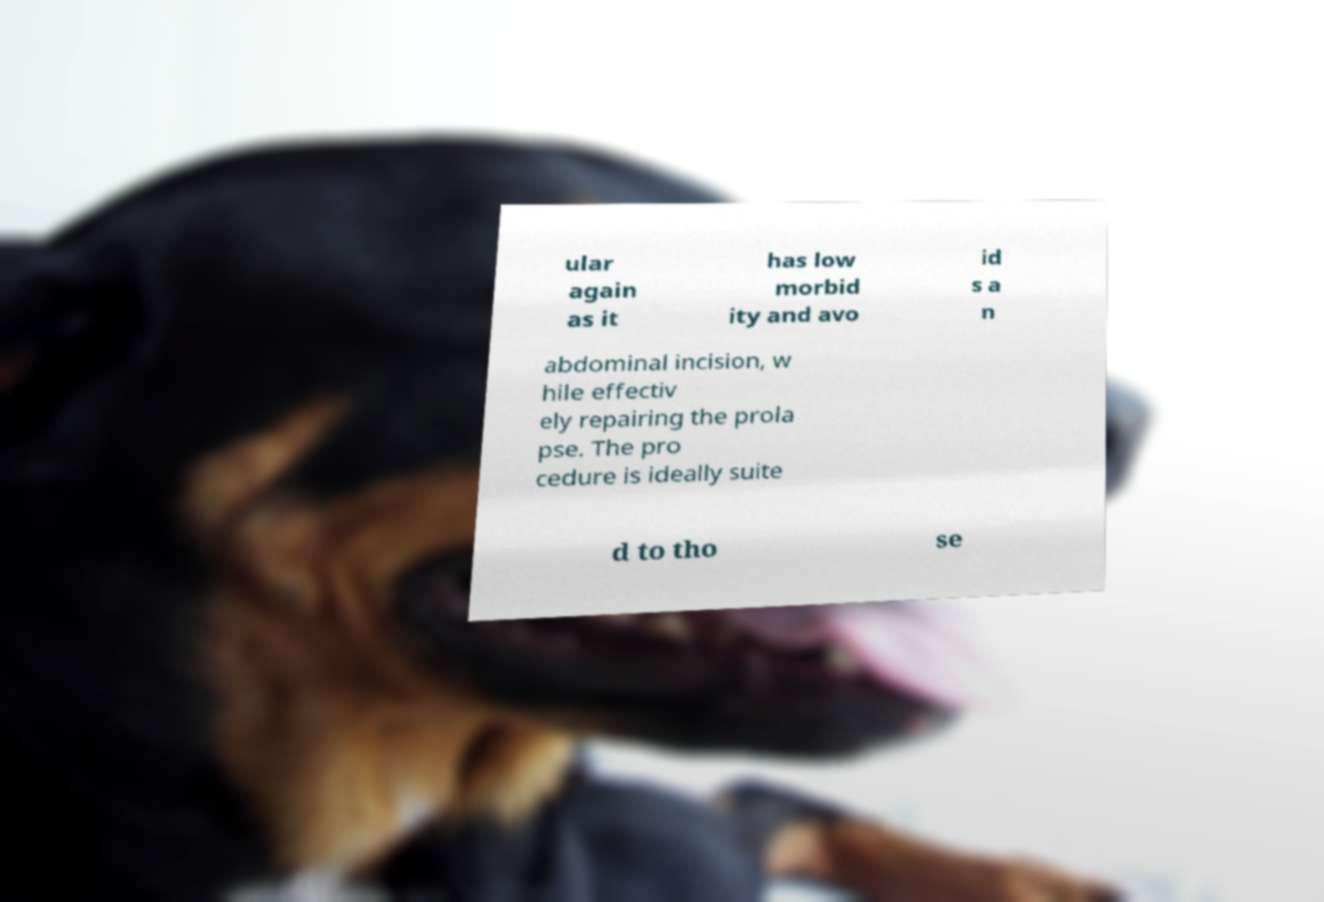Please read and relay the text visible in this image. What does it say? ular again as it has low morbid ity and avo id s a n abdominal incision, w hile effectiv ely repairing the prola pse. The pro cedure is ideally suite d to tho se 